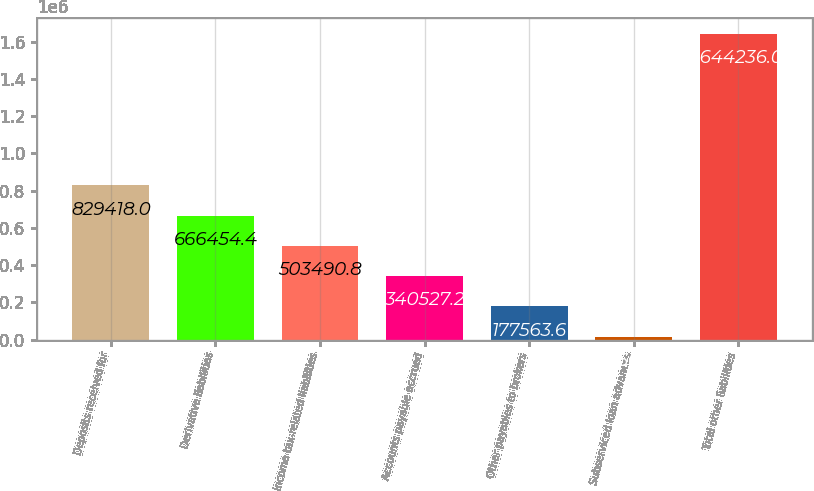<chart> <loc_0><loc_0><loc_500><loc_500><bar_chart><fcel>Deposits received for<fcel>Derivative liabilities<fcel>Income tax-related liabilities<fcel>Accounts payable accrued<fcel>Other payables to brokers<fcel>Subserviced loan advances<fcel>Total other liabilities<nl><fcel>829418<fcel>666454<fcel>503491<fcel>340527<fcel>177564<fcel>14600<fcel>1.64424e+06<nl></chart> 